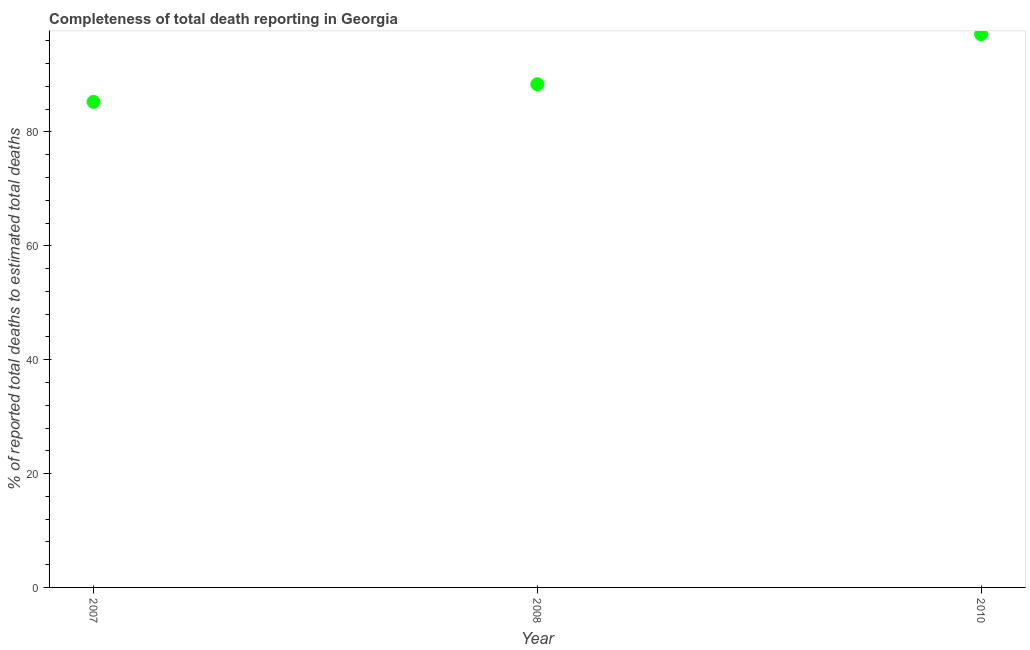What is the completeness of total death reports in 2010?
Provide a succinct answer. 97.18. Across all years, what is the maximum completeness of total death reports?
Your response must be concise. 97.18. Across all years, what is the minimum completeness of total death reports?
Your answer should be very brief. 85.29. In which year was the completeness of total death reports maximum?
Provide a succinct answer. 2010. In which year was the completeness of total death reports minimum?
Offer a very short reply. 2007. What is the sum of the completeness of total death reports?
Offer a terse response. 270.86. What is the difference between the completeness of total death reports in 2008 and 2010?
Your response must be concise. -8.78. What is the average completeness of total death reports per year?
Offer a very short reply. 90.29. What is the median completeness of total death reports?
Provide a short and direct response. 88.39. What is the ratio of the completeness of total death reports in 2008 to that in 2010?
Ensure brevity in your answer.  0.91. What is the difference between the highest and the second highest completeness of total death reports?
Offer a terse response. 8.78. What is the difference between the highest and the lowest completeness of total death reports?
Offer a very short reply. 11.88. How many dotlines are there?
Provide a succinct answer. 1. How many years are there in the graph?
Offer a terse response. 3. What is the title of the graph?
Your answer should be compact. Completeness of total death reporting in Georgia. What is the label or title of the X-axis?
Provide a short and direct response. Year. What is the label or title of the Y-axis?
Your answer should be compact. % of reported total deaths to estimated total deaths. What is the % of reported total deaths to estimated total deaths in 2007?
Offer a terse response. 85.29. What is the % of reported total deaths to estimated total deaths in 2008?
Your response must be concise. 88.39. What is the % of reported total deaths to estimated total deaths in 2010?
Make the answer very short. 97.18. What is the difference between the % of reported total deaths to estimated total deaths in 2007 and 2008?
Provide a short and direct response. -3.1. What is the difference between the % of reported total deaths to estimated total deaths in 2007 and 2010?
Ensure brevity in your answer.  -11.88. What is the difference between the % of reported total deaths to estimated total deaths in 2008 and 2010?
Keep it short and to the point. -8.78. What is the ratio of the % of reported total deaths to estimated total deaths in 2007 to that in 2008?
Ensure brevity in your answer.  0.96. What is the ratio of the % of reported total deaths to estimated total deaths in 2007 to that in 2010?
Make the answer very short. 0.88. What is the ratio of the % of reported total deaths to estimated total deaths in 2008 to that in 2010?
Make the answer very short. 0.91. 